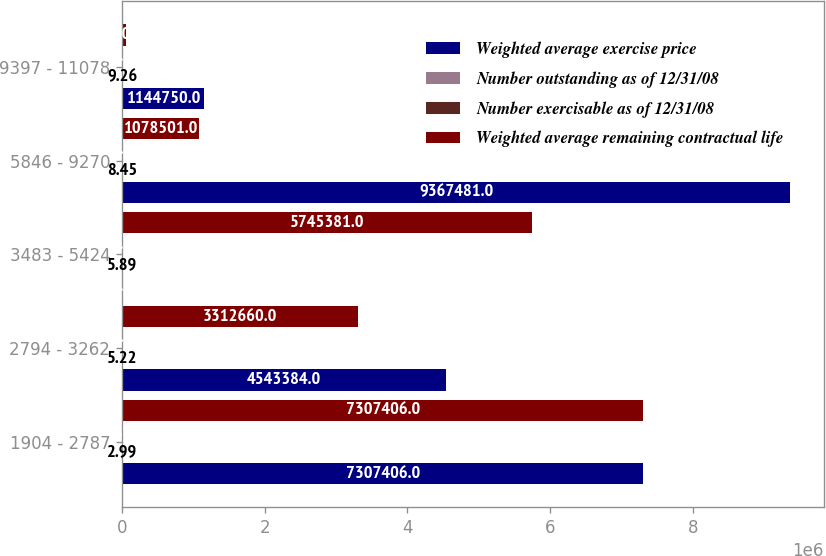Convert chart. <chart><loc_0><loc_0><loc_500><loc_500><stacked_bar_chart><ecel><fcel>1904 - 2787<fcel>2794 - 3262<fcel>3483 - 5424<fcel>5846 - 9270<fcel>9397 - 11078<nl><fcel>Weighted average exercise price<fcel>7.30741e+06<fcel>4.54338e+06<fcel>99.94<fcel>9.36748e+06<fcel>1.14475e+06<nl><fcel>Number outstanding as of 12/31/08<fcel>2.99<fcel>5.22<fcel>5.89<fcel>8.45<fcel>9.26<nl><fcel>Number exercisable as of 12/31/08<fcel>25.91<fcel>32.26<fcel>49.53<fcel>73.03<fcel>99.94<nl><fcel>Weighted average remaining contractual life<fcel>7.30741e+06<fcel>3.31266e+06<fcel>5.74538e+06<fcel>1.0785e+06<fcel>57200<nl></chart> 